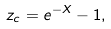Convert formula to latex. <formula><loc_0><loc_0><loc_500><loc_500>z _ { c } = e ^ { - X } - 1 ,</formula> 